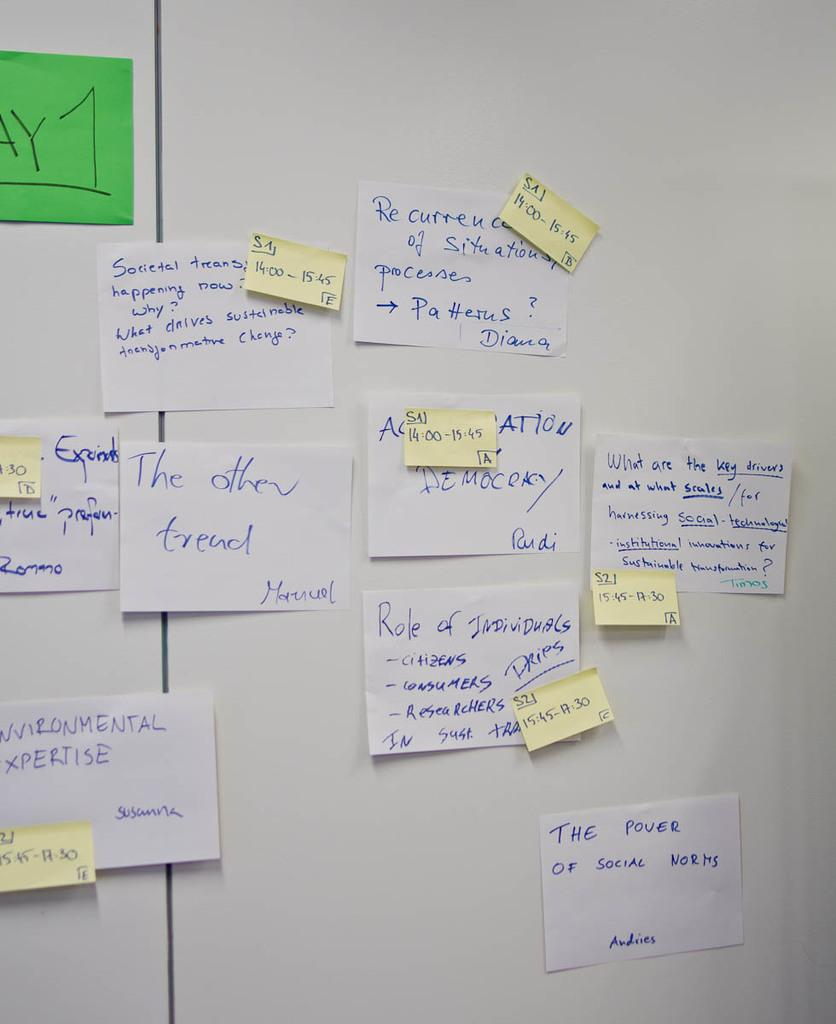<image>
Offer a succinct explanation of the picture presented. A white board has multiple papers and post it notes mentioning topics such as the environment, social change, and listing times for meetings. 